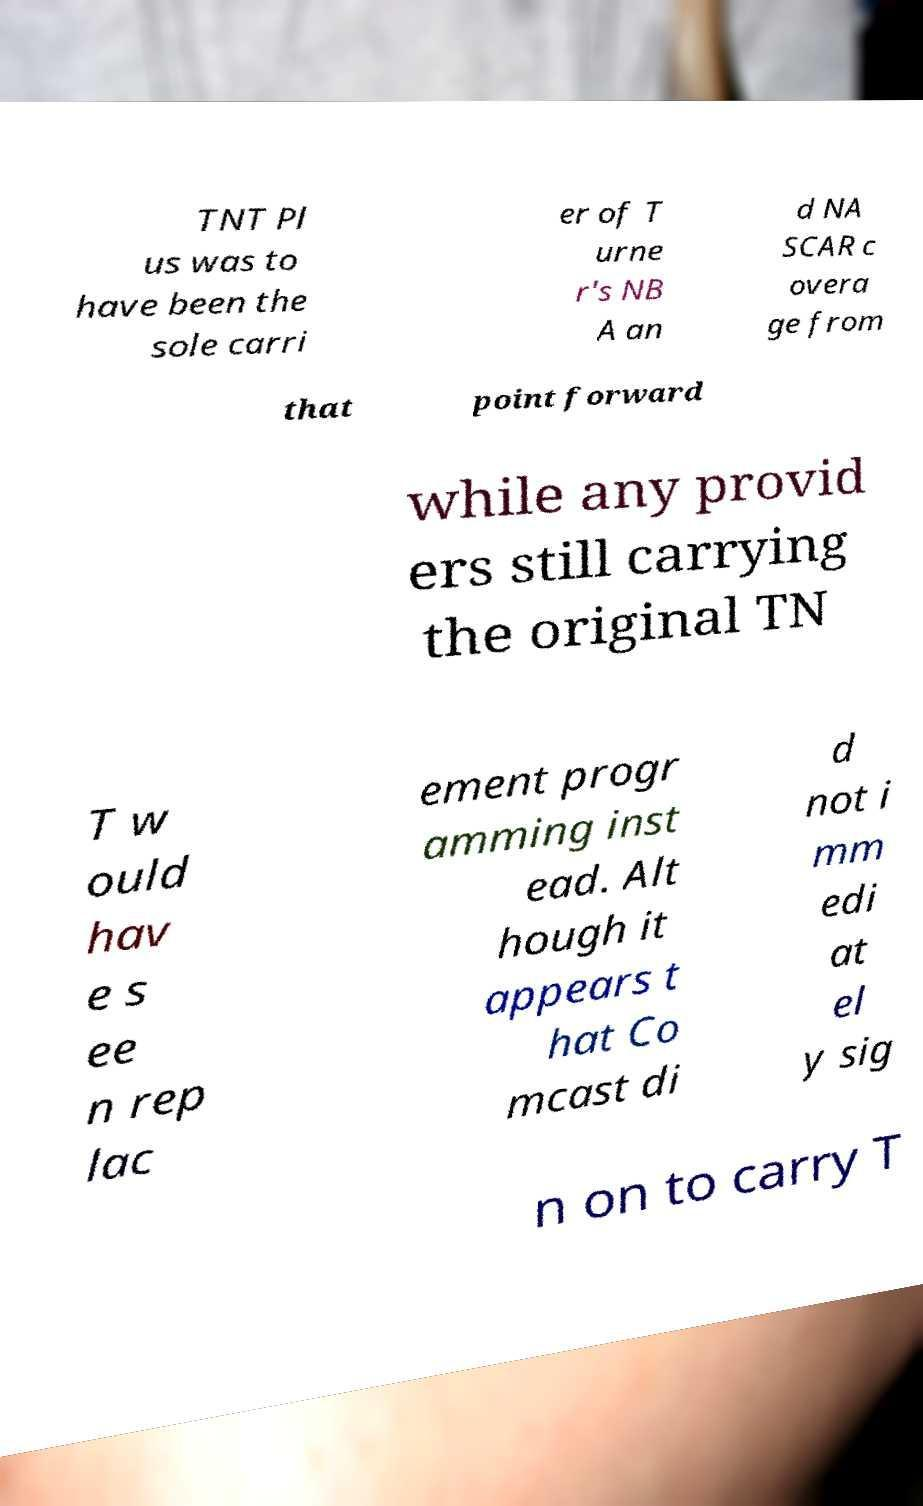For documentation purposes, I need the text within this image transcribed. Could you provide that? TNT Pl us was to have been the sole carri er of T urne r's NB A an d NA SCAR c overa ge from that point forward while any provid ers still carrying the original TN T w ould hav e s ee n rep lac ement progr amming inst ead. Alt hough it appears t hat Co mcast di d not i mm edi at el y sig n on to carry T 